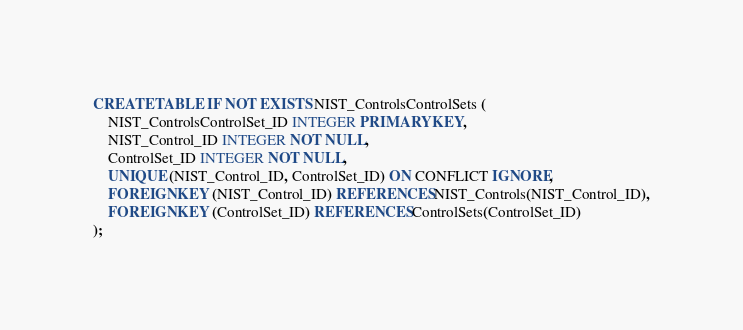<code> <loc_0><loc_0><loc_500><loc_500><_SQL_>CREATE TABLE IF NOT EXISTS NIST_ControlsControlSets (
    NIST_ControlsControlSet_ID INTEGER PRIMARY KEY,
    NIST_Control_ID INTEGER NOT NULL,
    ControlSet_ID INTEGER NOT NULL,
    UNIQUE (NIST_Control_ID, ControlSet_ID) ON CONFLICT IGNORE,
    FOREIGN KEY (NIST_Control_ID) REFERENCES NIST_Controls(NIST_Control_ID),
    FOREIGN KEY (ControlSet_ID) REFERENCES ControlSets(ControlSet_ID)
);</code> 